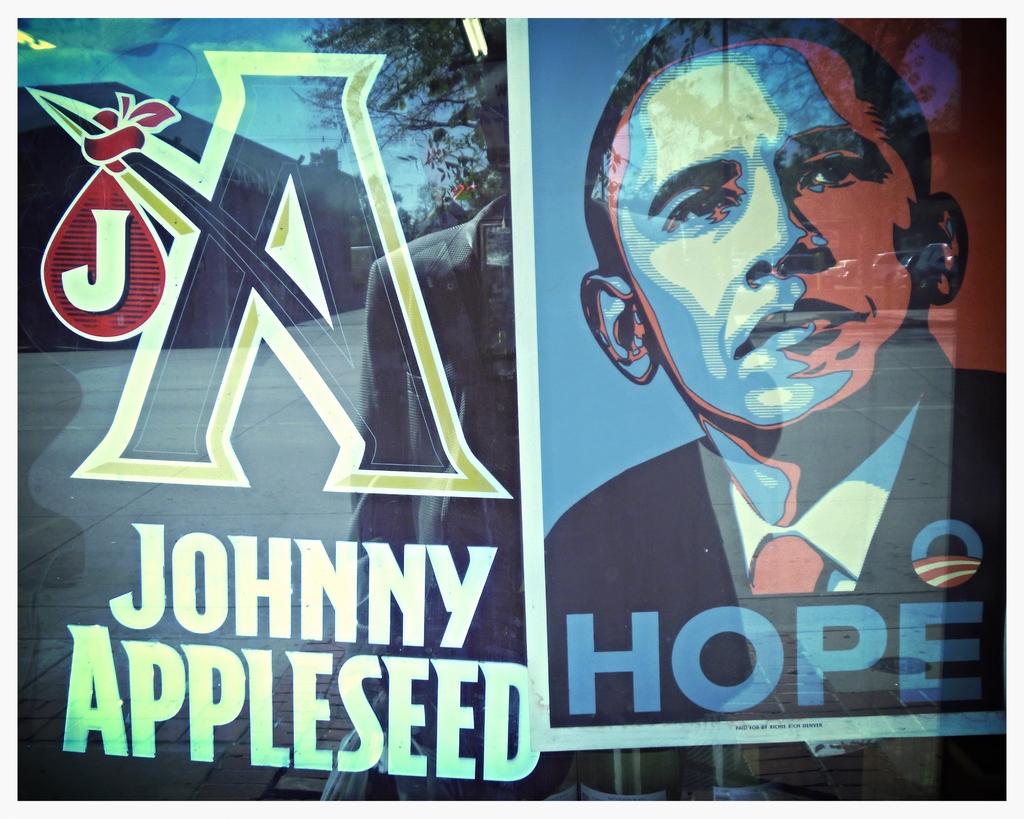What is johnny's last name?
Offer a very short reply. Appleseed. What quote is being attributed to obama?
Provide a short and direct response. Hope. 